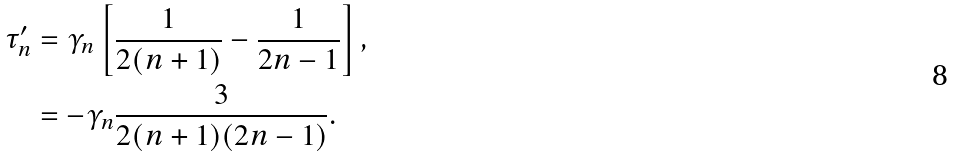Convert formula to latex. <formula><loc_0><loc_0><loc_500><loc_500>\tau ^ { \prime } _ { n } & = \gamma _ { n } \left [ \frac { 1 } { 2 ( n + 1 ) } - \frac { 1 } { 2 n - 1 } \right ] , \\ & = - \gamma _ { n } \frac { 3 } { 2 ( n + 1 ) ( 2 n - 1 ) } . \\</formula> 